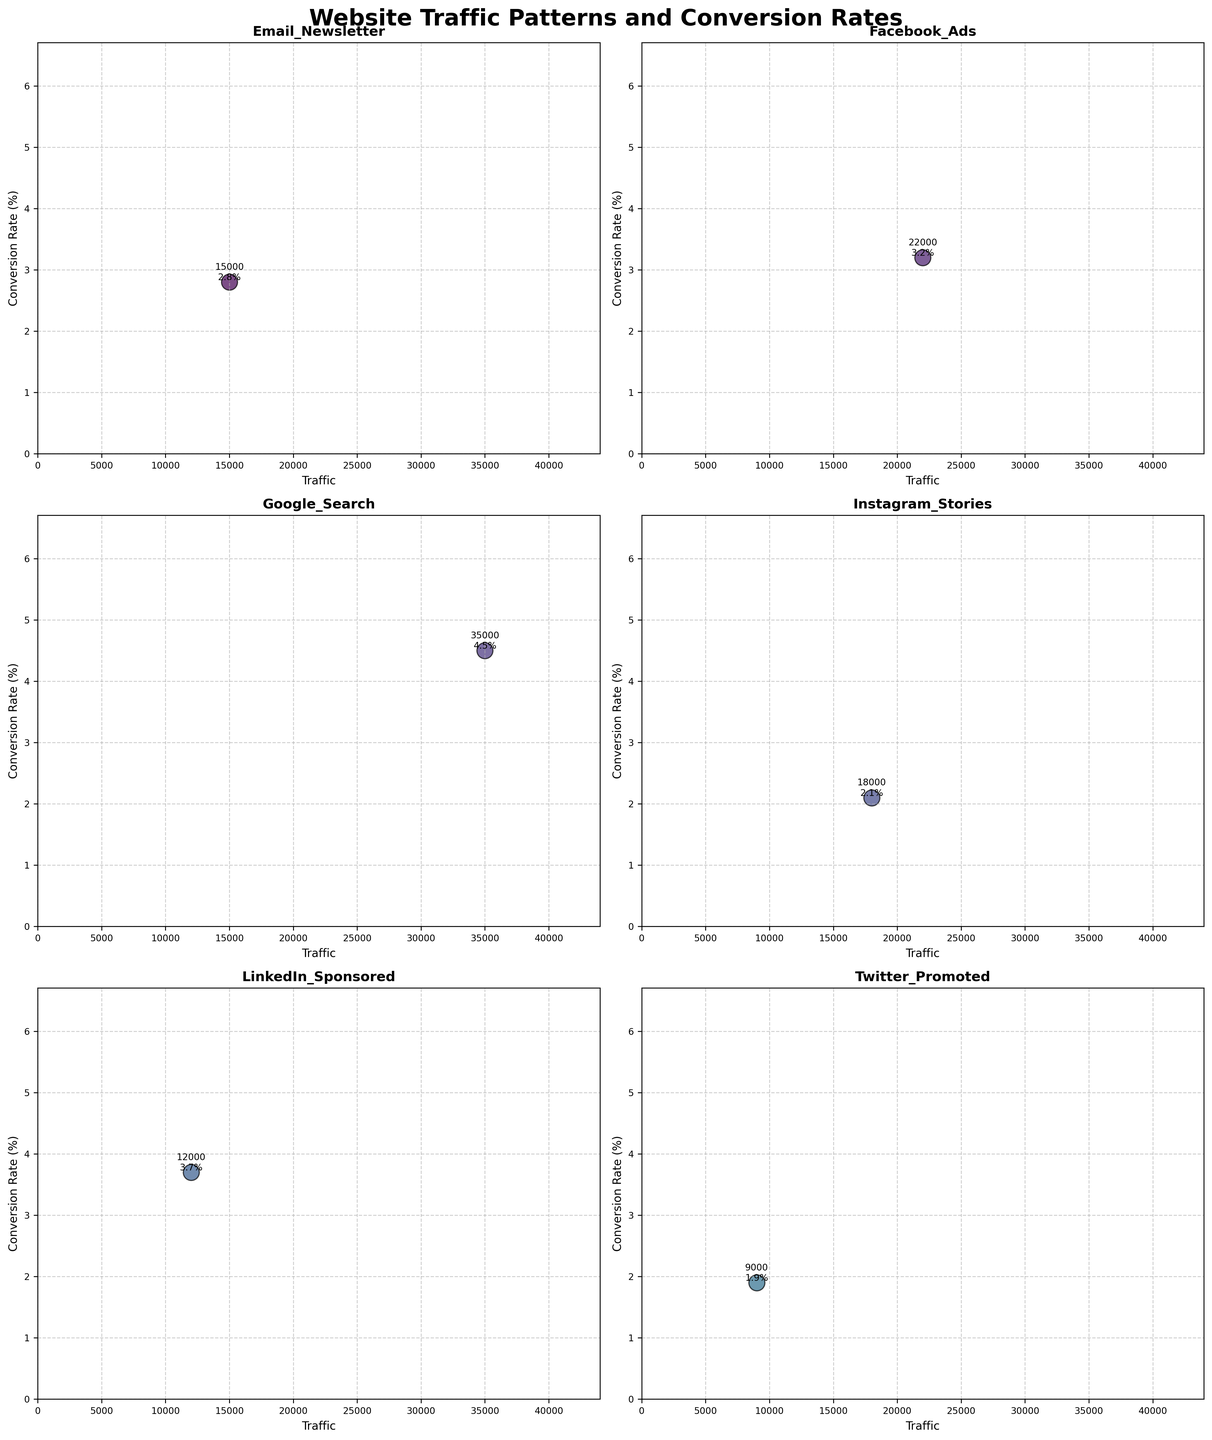What is the title of the figure? The title is located at the top center of the figure and states the subject of the visualization. In this case, it reads "Website Traffic Patterns and Conversion Rates" in bold.
Answer: Website Traffic Patterns and Conversion Rates How many marketing campaigns are being compared in the figure? Each subplot displays one marketing campaign, and there are a total of 6 subplots in the figure. By counting the subplots, we determine the number of campaigns being compared.
Answer: 6 Which campaign has the highest conversion rate in this figure? By examining the y-axis of each subplot and comparing the conversion rates, we see that the "Retargeting Ads" campaign has the highest conversion rate value of 5.2%.
Answer: Retargeting Ads Between the "Google Search" and "SEO Organic" campaigns, which one has higher traffic? Look for the two specific subplots "Google Search" and "SEO Organic" and compare their traffic values on the x-axis. The "Google Search" campaign shows 35,000 traffic, while "SEO Organic" shows 40,000.
Answer: SEO Organic Which campaign has the lowest conversion rate in this figure? By looking at the y-axis of each subplot and identifying the smallest value, the "Display Banners" campaign has the lowest conversion rate of 1.5%.
Answer: Display Banners What is the average conversion rate for all campaigns shown? Sum up the conversion rates for each campaign and divide by the number of campaigns displayed in the subplots. This includes 2.8, 3.2, 4.5, 2.1, 3.7, 1.9, 3.5, 1.5, 4.8, 3.9, 2.3, 3.1, 5.2, 6.1, 4.2. So, the sum is 52.8 and the number of campaigns is 15.
Answer: 3.52 What can be said about the correlation between traffic and conversion rates from the subplots in the figure? Observe whether there is any apparent trend or pattern across the subplots. If higher traffic tends to align with higher or lower conversion rates, or if no clear pattern exists, then note this observation.
Answer: Mixed Which campaign has the most balanced ratio of traffic to conversion rate? Calculate the ratio of traffic to conversion rate for each campaign, looking for the one where the values are close, indicating a balanced performance. Examples like "Referral Program" with 10,000 traffic and 6.1% conversion rate are balanced.
Answer: Referral Program Comparing "Facebook Ads" and "Instagram Stories," which one has a higher conversion rate? Locate the subplots for "Facebook Ads" and "Instagram Stories" and compare their y-axis values. "Facebook Ads" has a conversion rate of 3.2%, while "Instagram Stories" has 2.1%.
Answer: Facebook Ads 